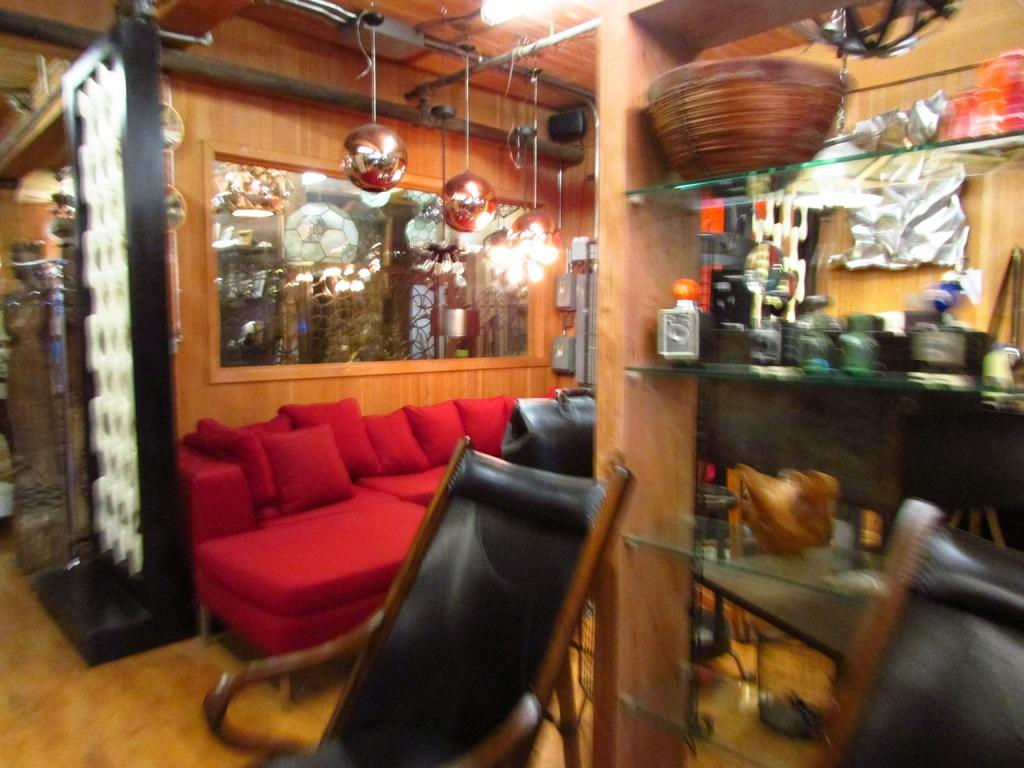What type of furniture is present in the image? There is a sofa set and chairs in the image. What other object can be seen in the image? There is a shelf in the image. What feature allows natural light to enter the room? There is a glass window in the image. What color are the toes of the person sitting on the sofa in the image? There is no person or toes visible in the image; it only shows furniture and a shelf. 